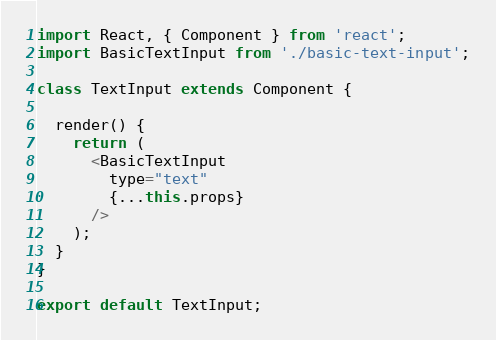<code> <loc_0><loc_0><loc_500><loc_500><_JavaScript_>import React, { Component } from 'react';
import BasicTextInput from './basic-text-input';

class TextInput extends Component {

  render() {
    return (
      <BasicTextInput
        type="text"
        {...this.props}
      />
    );
  }
}

export default TextInput;
</code> 